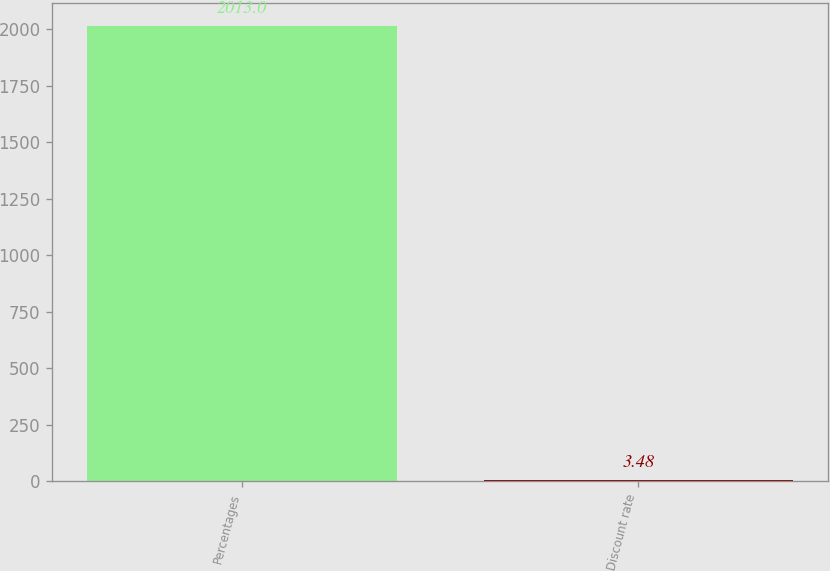Convert chart to OTSL. <chart><loc_0><loc_0><loc_500><loc_500><bar_chart><fcel>Percentages<fcel>Discount rate<nl><fcel>2013<fcel>3.48<nl></chart> 